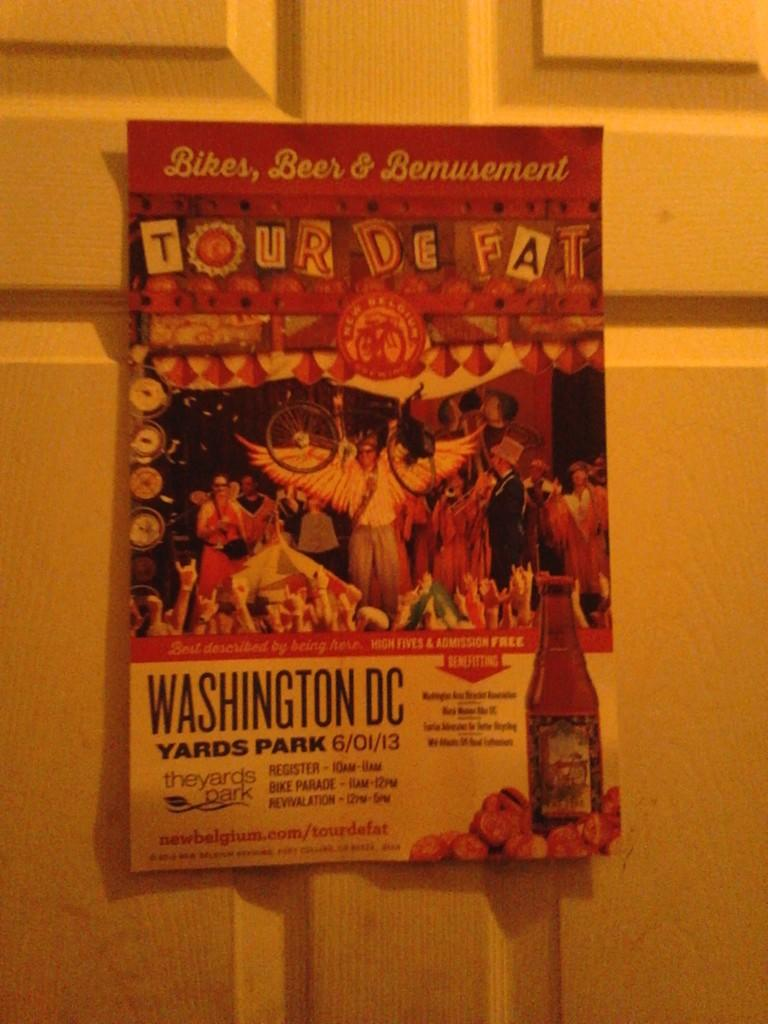Provide a one-sentence caption for the provided image. A colorful sign for the Tour De Fat hangs on a door. 